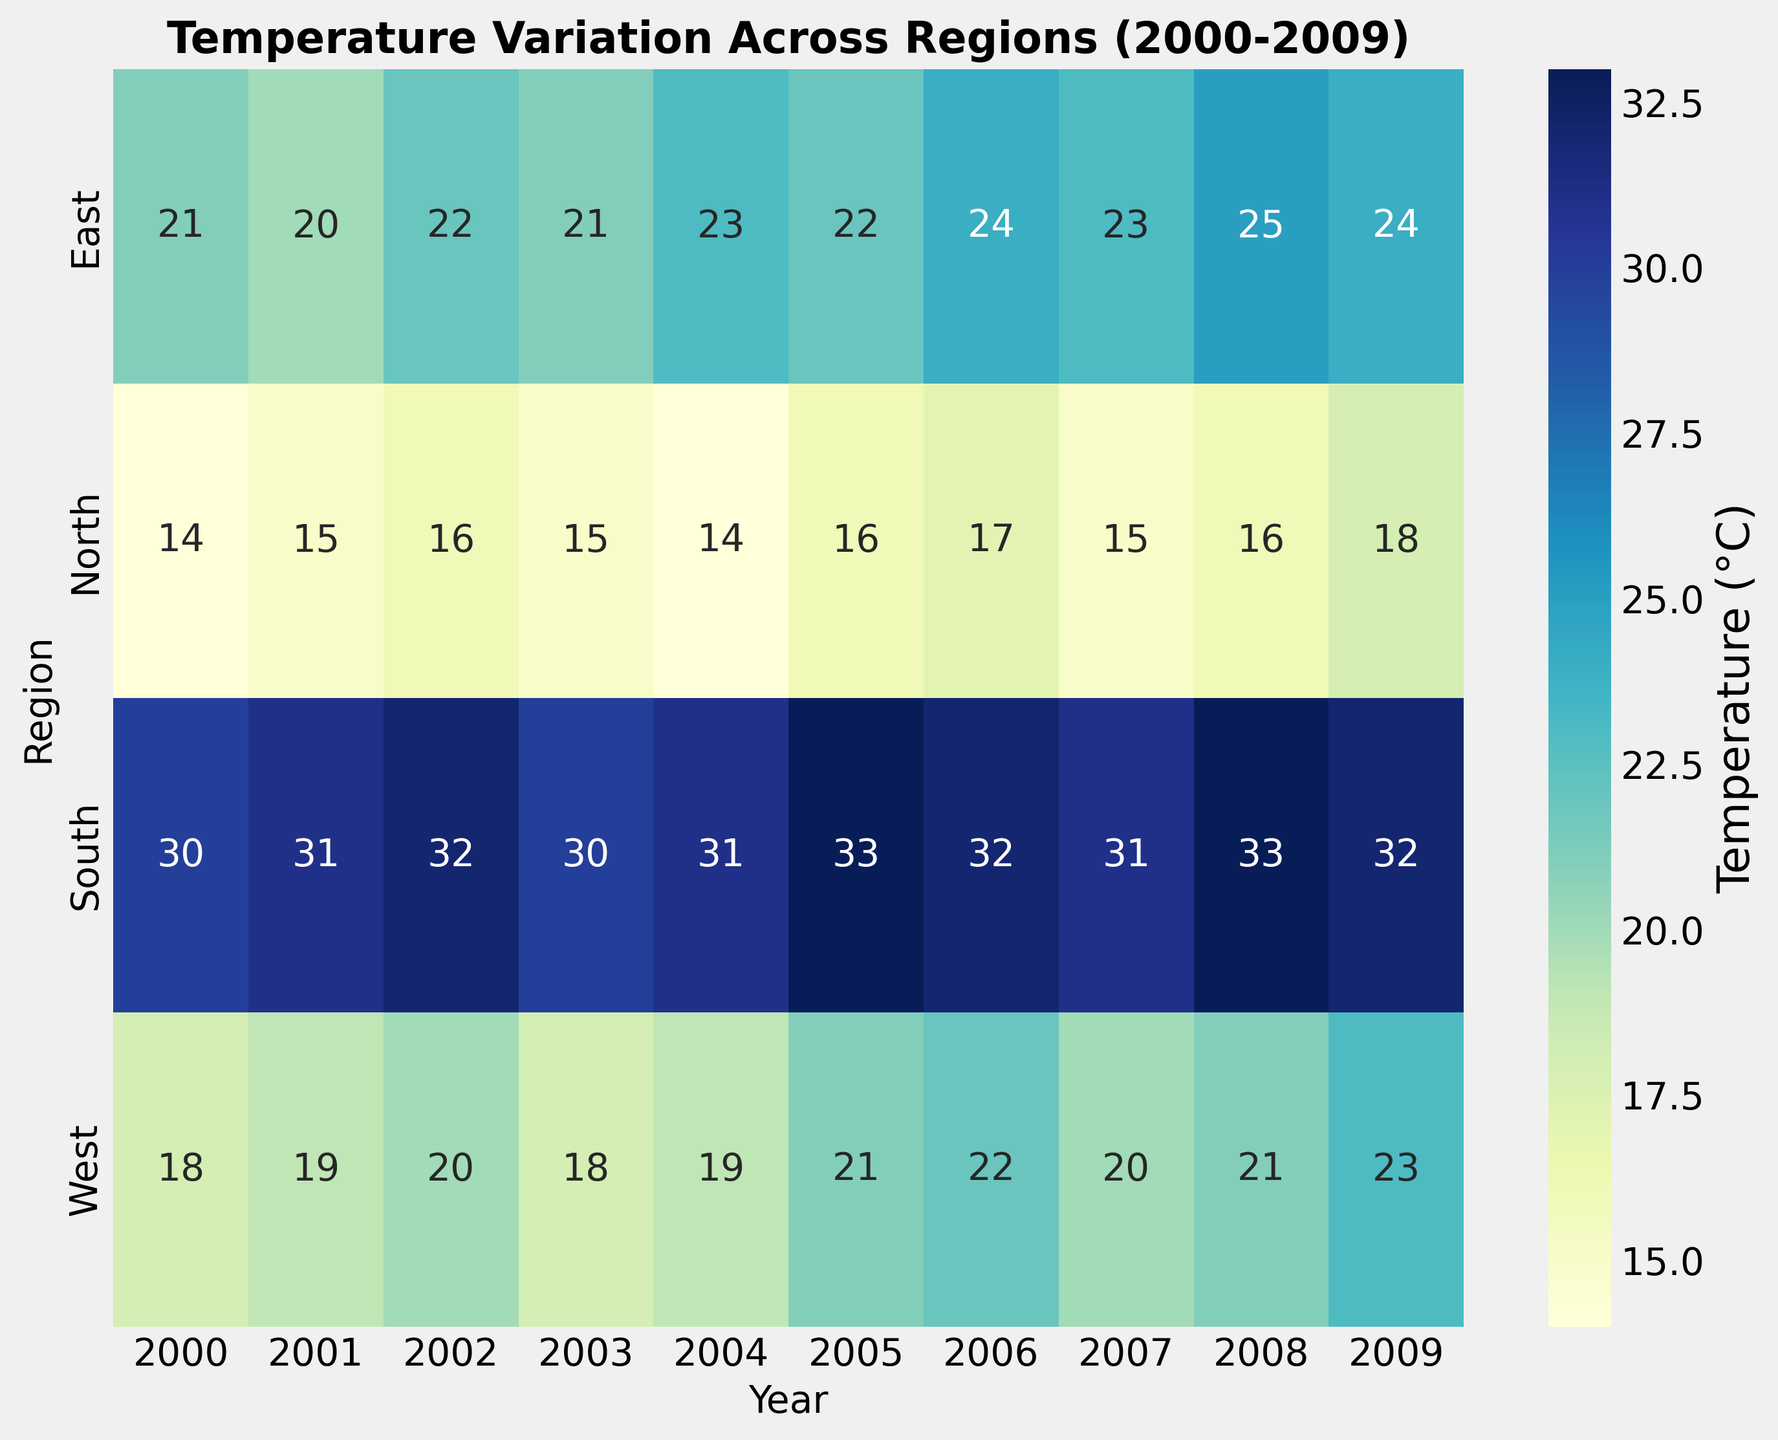Which region has the highest temperature in 2008? To find the highest temperature in 2008, scan the column for 2008 and identify the highest numerical value, which is associated with the South region.
Answer: South What is the average temperature of the North region from 2000 to 2009? Sum the temperatures for the North region from 2000 to 2009: (14 + 15 + 16 + 15 + 14 + 16 + 17 + 15 + 16 + 18), which equals 156. Divide this sum by the number of years (10) to get the average.
Answer: 15.6 Was the temperature in the East region consistently increasing from 2006 to 2009? Check the East region's temperature values for the years 2006 through 2009: (2006: 24, 2007: 23, 2008: 25, 2009: 24). These values do not show a consistent increase; there are fluctuations.
Answer: No Which region shows the least variation in temperature over the years? Look at the numerical range (difference between maximum and minimum temperatures) for each region. The North region has the least range, from 14 to 18, which is a difference of 4.
Answer: North Compare the average temperatures of the South and West regions from 2000 to 2009. Which one is higher? Calculate the total temperature for South (301) and West (201) over the years, then divide each by 10. The average for South is 30.1 and for West is 20.1. So, the South region has a higher average temperature.
Answer: South What is the temperature difference between the hottest and coldest regions in 2005? Identify the highest and lowest temperatures in 2005: South (33) and North (16). The difference is 33 - 16.
Answer: 17 Did the temperature in the North region increase, decrease, or stay the same from 2004 to 2005? Compare the temperatures for the North region in 2004 (14) and 2005 (16). The temperature increased.
Answer: Increased What region had the lowest temperature in 2007? Identify the lowest temperature in 2007 across all regions. The North region had the lowest temperature of 15.
Answer: North Was there any year where all regions had increased temperature compared to the previous year? Examine each year and check if all regions' temperatures increased from the previous year. No year fits this criteria as all regions never simultaneously increased their temperatures.
Answer: No 